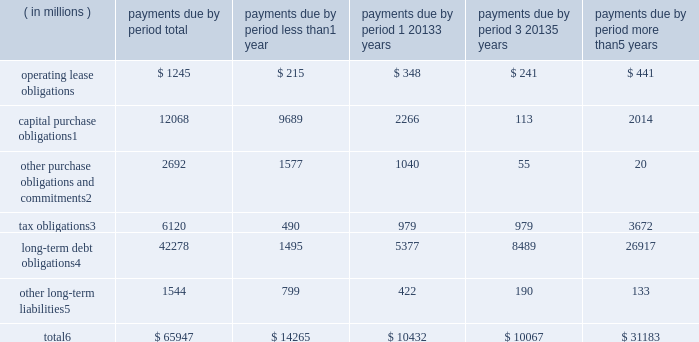Contractual obligations significant contractual obligations as of december 30 , 2017 were as follows: .
Capital purchase obligations1 12068 9689 2266 113 2014 other purchase obligations and commitments2 2692 1577 1040 55 20 tax obligations3 6120 490 979 979 3672 long-term debt obligations4 42278 1495 5377 8489 26917 other long-term liabilities5 1544 799 422 190 133 total6 $ 65947 $ 14265 $ 10432 $ 10067 $ 31183 1 capital purchase obligations represent commitments for the construction or purchase of property , plant and equipment .
They were not recorded as liabilities on our consolidated balance sheets as of december 30 , 2017 , as we had not yet received the related goods nor taken title to the property .
2 other purchase obligations and commitments include payments due under various types of licenses and agreements to purchase goods or services , as well as payments due under non-contingent funding obligations .
3 tax obligations represent the future cash payments related to tax reform enacted in 2017 for the one-time provisional transition tax on our previously untaxed foreign earnings .
For further information , see 201cnote 8 : income taxes 201d within the consolidated financial statements .
4 amounts represent principal and interest cash payments over the life of the debt obligations , including anticipated interest payments that are not recorded on our consolidated balance sheets .
Debt obligations are classified based on their stated maturity date , regardless of their classification on the consolidated balance sheets .
Any future settlement of convertible debt would impact our cash payments .
5 amounts represent future cash payments to satisfy other long-term liabilities recorded on our consolidated balance sheets , including the short-term portion of these long-term liabilities .
Derivative instruments are excluded from the preceding table , as they do not represent the amounts that may ultimately be paid .
6 total excludes contractual obligations already recorded on our consolidated balance sheets as current liabilities , except for the short-term portions of long-term debt obligations and other long-term liabilities .
The expected timing of payments of the obligations in the preceding table is estimated based on current information .
Timing of payments and actual amounts paid may be different , depending on the time of receipt of goods or services , or changes to agreed- upon amounts for some obligations .
Contractual obligations for purchases of goods or services included in 201cother purchase obligations and commitments 201d in the preceding table include agreements that are enforceable and legally binding on intel and that specify all significant terms , including fixed or minimum quantities to be purchased ; fixed , minimum , or variable price provisions ; and the approximate timing of the transaction .
For obligations with cancellation provisions , the amounts included in the preceding table were limited to the non-cancelable portion of the agreement terms or the minimum cancellation fee .
For the purchase of raw materials , we have entered into certain agreements that specify minimum prices and quantities based on a percentage of the total available market or based on a percentage of our future purchasing requirements .
Due to the uncertainty of the future market and our future purchasing requirements , as well as the non-binding nature of these agreements , obligations under these agreements have been excluded from the preceding table .
Our purchase orders for other products are based on our current manufacturing needs and are fulfilled by our vendors within short time horizons .
In addition , some of our purchase orders represent authorizations to purchase rather than binding agreements .
Contractual obligations that are contingent upon the achievement of certain milestones have been excluded from the preceding table .
Most of our milestone-based contracts are tooling related for the purchase of capital equipment .
These arrangements are not considered contractual obligations until the milestone is met by the counterparty .
As of december 30 , 2017 , assuming that all future milestones are met , the additional required payments would be approximately $ 2.0 billion .
For the majority of restricted stock units ( rsus ) granted , the number of shares of common stock issued on the date the rsus vest is net of the minimum statutory withholding requirements that we pay in cash to the appropriate taxing authorities on behalf of our employees .
The obligation to pay the relevant taxing authority is excluded from the preceding table , as the amount is contingent upon continued employment .
In addition , the amount of the obligation is unknown , as it is based in part on the market price of our common stock when the awards vest .
Md&a - results of operations consolidated results and analysis 38 .
As of december 30 , 2017 what was the percent of the capital purchase obligations to the total? 
Rationale: as of december 30 , 2017 18.3% of the total was made of the capital purchase obligations
Computations: (12068 / 65947)
Answer: 0.183. 